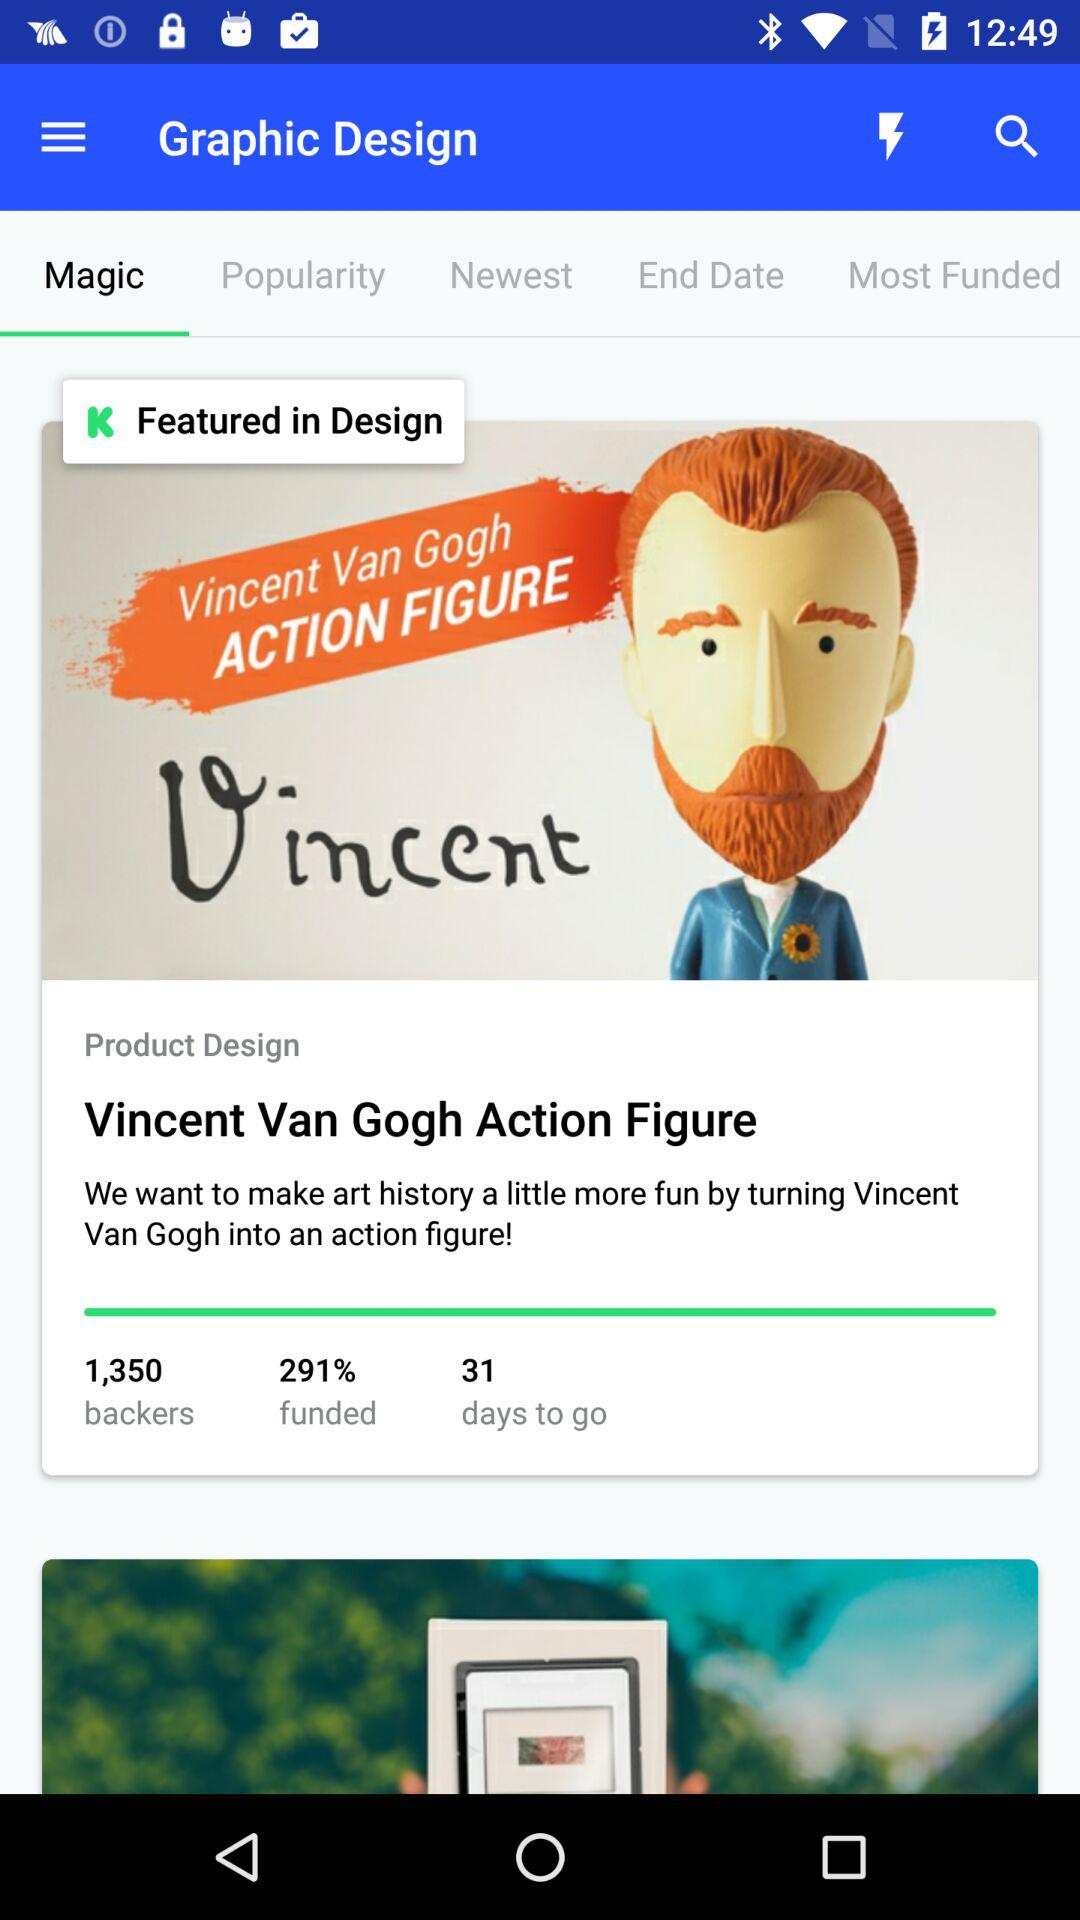What is the application name? The application name is "Graphic Design". 